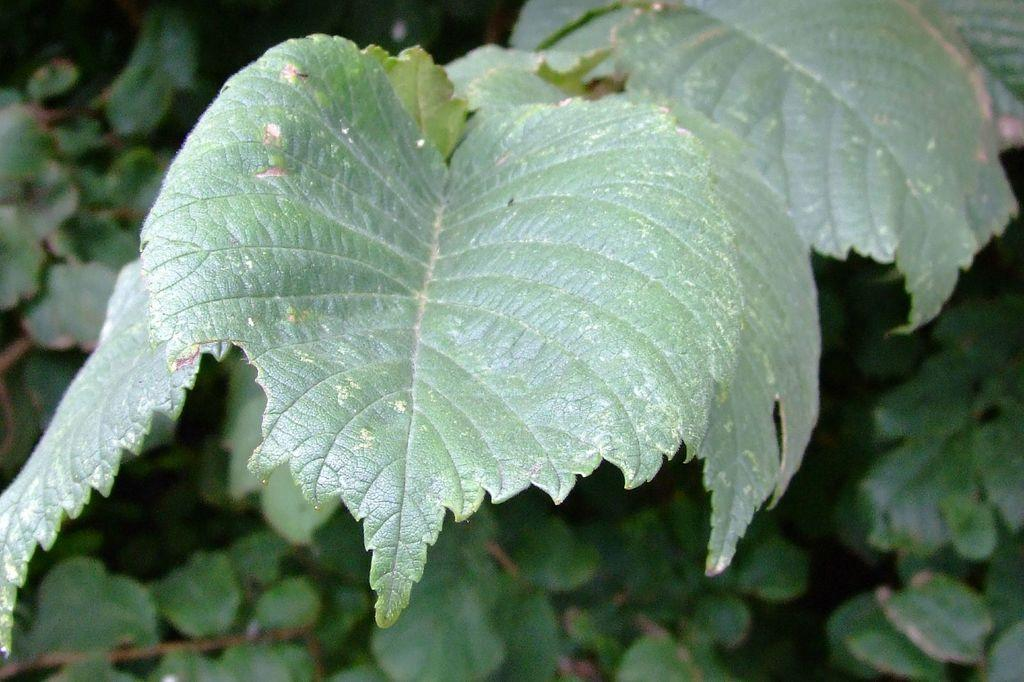What type of vegetation can be seen in the image? There are leaves in the image. What is the color of the leaves? The leaves are green in color. What can be seen in the background of the image? There are trees in the background of the image. What colors are the trees? The trees are green and brown in color. What time of day is it in the image, and is there a visitor present? The time of day and the presence of a visitor cannot be determined from the image, as it only shows leaves and trees. 